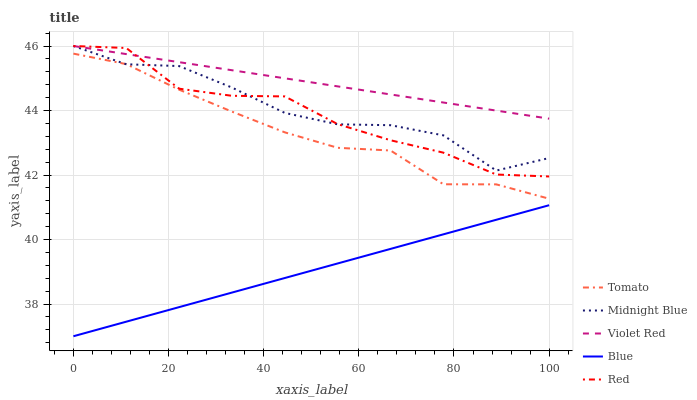Does Blue have the minimum area under the curve?
Answer yes or no. Yes. Does Violet Red have the maximum area under the curve?
Answer yes or no. Yes. Does Violet Red have the minimum area under the curve?
Answer yes or no. No. Does Blue have the maximum area under the curve?
Answer yes or no. No. Is Blue the smoothest?
Answer yes or no. Yes. Is Red the roughest?
Answer yes or no. Yes. Is Violet Red the smoothest?
Answer yes or no. No. Is Violet Red the roughest?
Answer yes or no. No. Does Violet Red have the lowest value?
Answer yes or no. No. Does Red have the highest value?
Answer yes or no. Yes. Does Blue have the highest value?
Answer yes or no. No. Is Blue less than Violet Red?
Answer yes or no. Yes. Is Midnight Blue greater than Blue?
Answer yes or no. Yes. Does Midnight Blue intersect Red?
Answer yes or no. Yes. Is Midnight Blue less than Red?
Answer yes or no. No. Is Midnight Blue greater than Red?
Answer yes or no. No. Does Blue intersect Violet Red?
Answer yes or no. No. 